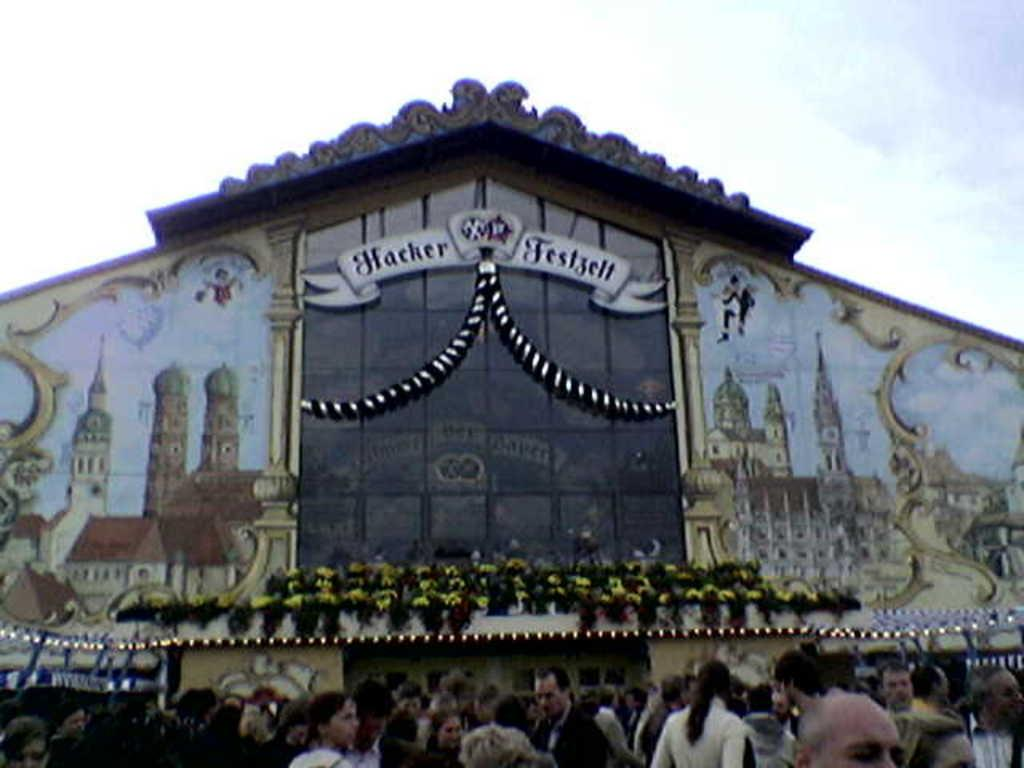<image>
Create a compact narrative representing the image presented. A Hacker Festival sign hangs in front of a large set of windows on a building. 